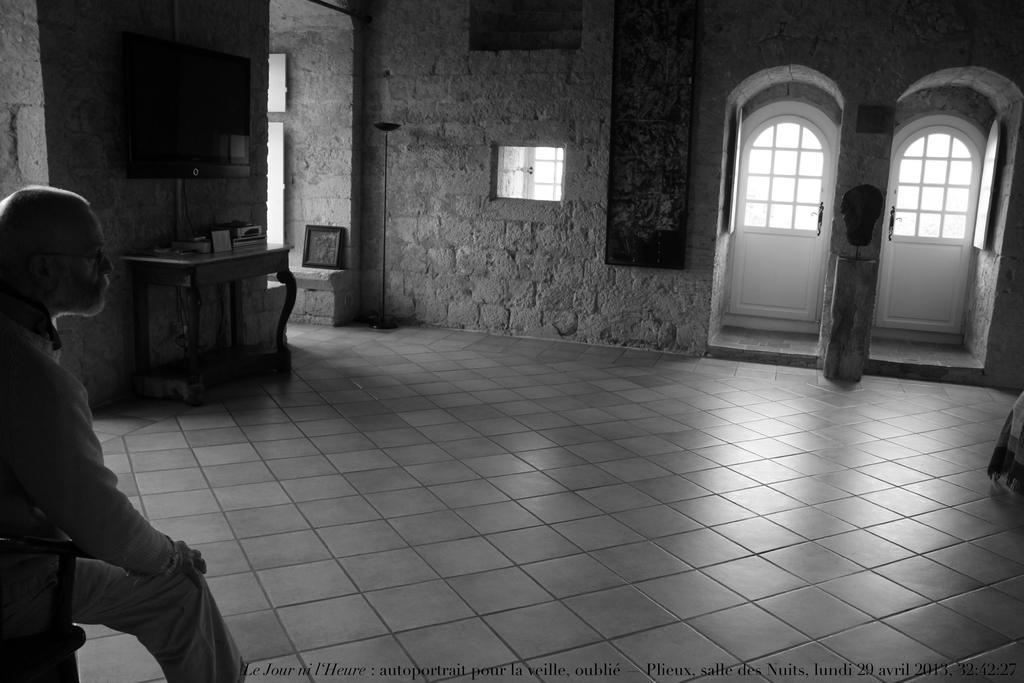Describe this image in one or two sentences. It is a closed room. On the left corner of the picture one person is sitting on the chair behind him there is wall and table and a tv is placed on the wall, on the table there are things, at the right corner of the picture there are two doors and one big wall with window is present. 